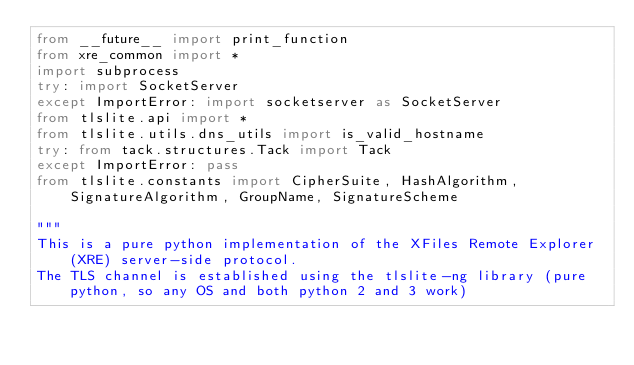<code> <loc_0><loc_0><loc_500><loc_500><_Python_>from __future__ import print_function
from xre_common import *
import subprocess
try: import SocketServer
except ImportError: import socketserver as SocketServer
from tlslite.api import *
from tlslite.utils.dns_utils import is_valid_hostname
try: from tack.structures.Tack import Tack
except ImportError: pass
from tlslite.constants import CipherSuite, HashAlgorithm, SignatureAlgorithm, GroupName, SignatureScheme

"""
This is a pure python implementation of the XFiles Remote Explorer (XRE) server-side protocol.
The TLS channel is established using the tlslite-ng library (pure python, so any OS and both python 2 and 3 work)</code> 